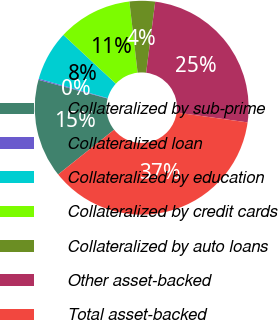<chart> <loc_0><loc_0><loc_500><loc_500><pie_chart><fcel>Collateralized by sub-prime<fcel>Collateralized loan<fcel>Collateralized by education<fcel>Collateralized by credit cards<fcel>Collateralized by auto loans<fcel>Other asset-backed<fcel>Total asset-backed<nl><fcel>14.93%<fcel>0.17%<fcel>7.55%<fcel>11.24%<fcel>3.86%<fcel>25.17%<fcel>37.09%<nl></chart> 